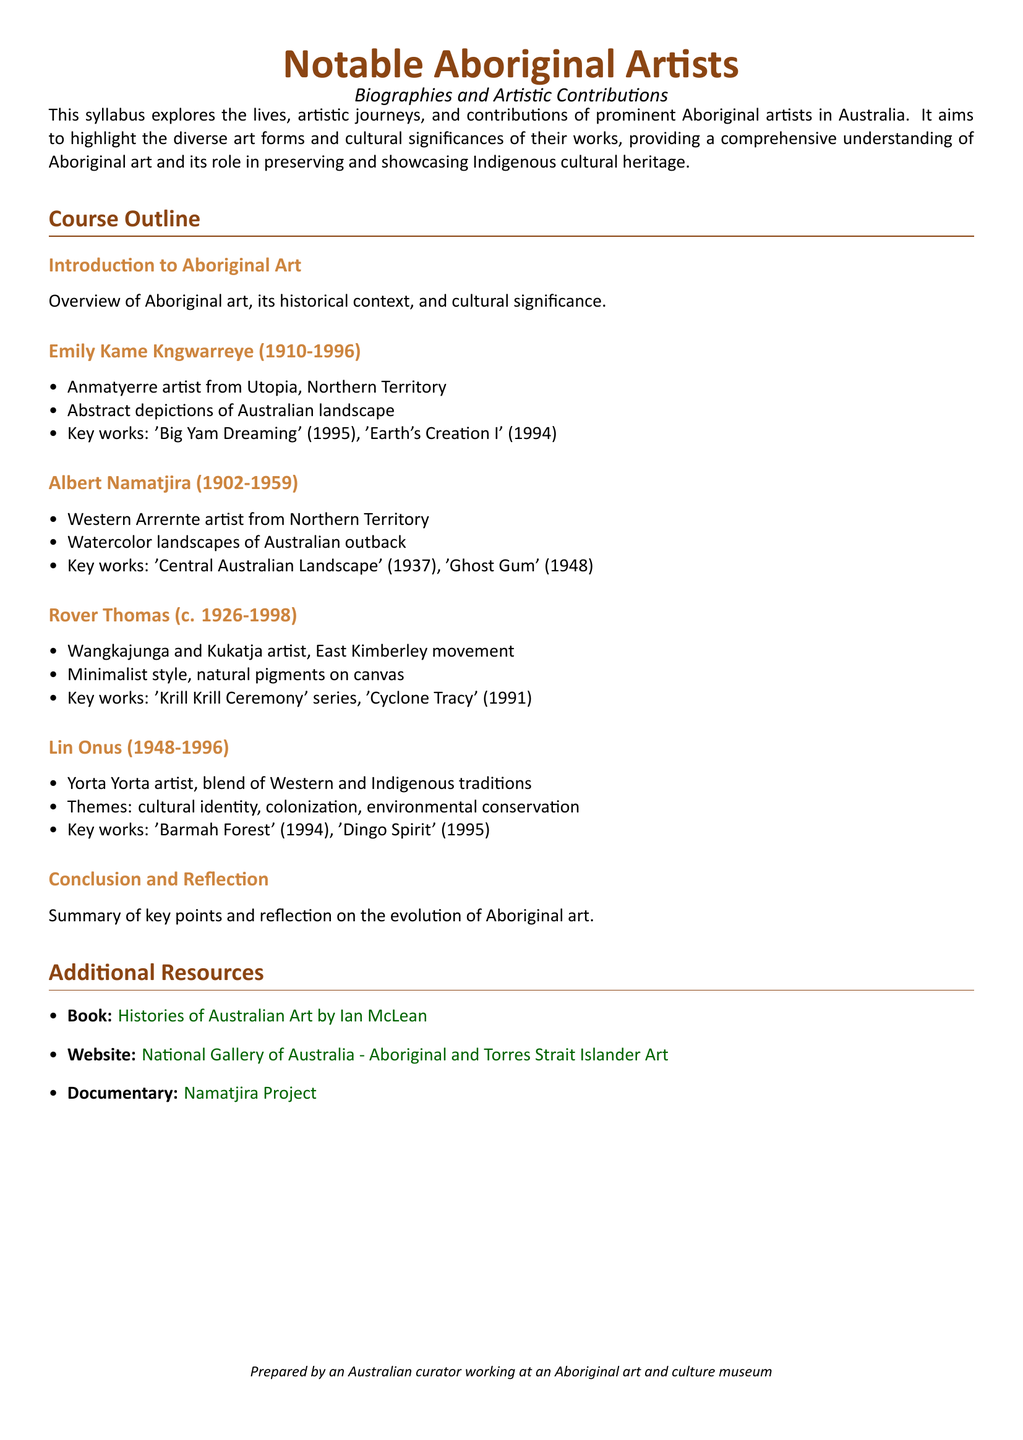What is the main focus of the syllabus? The syllabus explores lives, artistic journeys, and contributions of prominent Aboriginal artists, and highlights the diverse art forms and cultural significance of their works.
Answer: Aboriginal artists Who is the Anmatyerre artist mentioned? The document lists Emily Kame Kngwarreye as an Anmatyerre artist from Utopia, Northern Territory.
Answer: Emily Kame Kngwarreye What is one key work of Albert Namatjira? The syllabus states that one of Albert Namatjira's key works is 'Central Australian Landscape' (1937).
Answer: Central Australian Landscape In which year was Emily Kame Kngwarreye born? The document indicates that Emily Kame Kngwarreye was born in 1910.
Answer: 1910 What is the common theme in Lin Onus's artwork? The syllabus mentions that Lin Onus's themes include cultural identity, colonization, and environmental conservation.
Answer: Cultural identity What artistic style is associated with Rover Thomas? The document describes Rover Thomas's style as minimalist using natural pigments on canvas.
Answer: Minimalist How many artists are featured in the syllabus? The syllabus includes five notable Aboriginal artists throughout its outline.
Answer: Five What type of resources are provided at the end of the syllabus? The document lists additional resources such as books, websites, and documentaries related to Aboriginal art.
Answer: Additional resources 